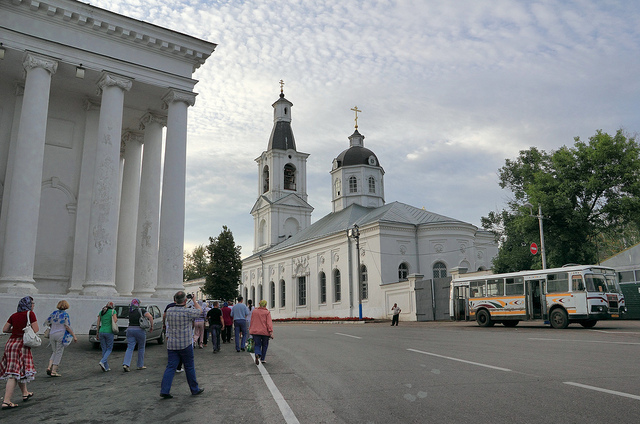<image>What is the purpose for the front building? I don't know the exact purpose of the front building. It could be a church, a government building, an entrance, or a theater. What type of tree is on the right? It is ambiguous what type of tree is on the right, it can be an elm, maple, fir or oak tree. What is the purpose for the front building? I don't know the purpose for the front building. It can be church, government, entrance, art or theater. What type of tree is on the right? I don't know what type of tree is on the right. It could be elm, maple, fir, or oak. 